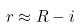<formula> <loc_0><loc_0><loc_500><loc_500>r \approx R - i</formula> 